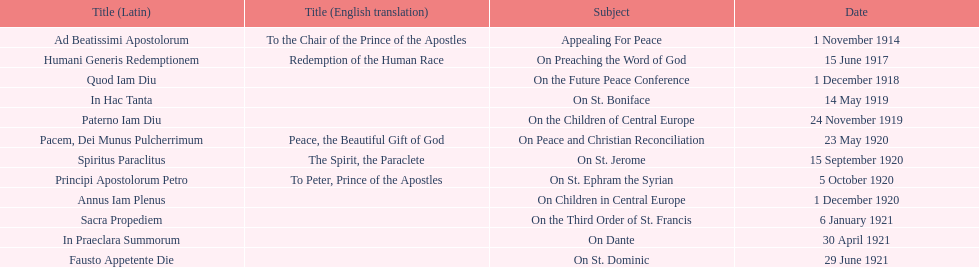After advocating for peace, what subject is discussed next? On Preaching the Word of God. 